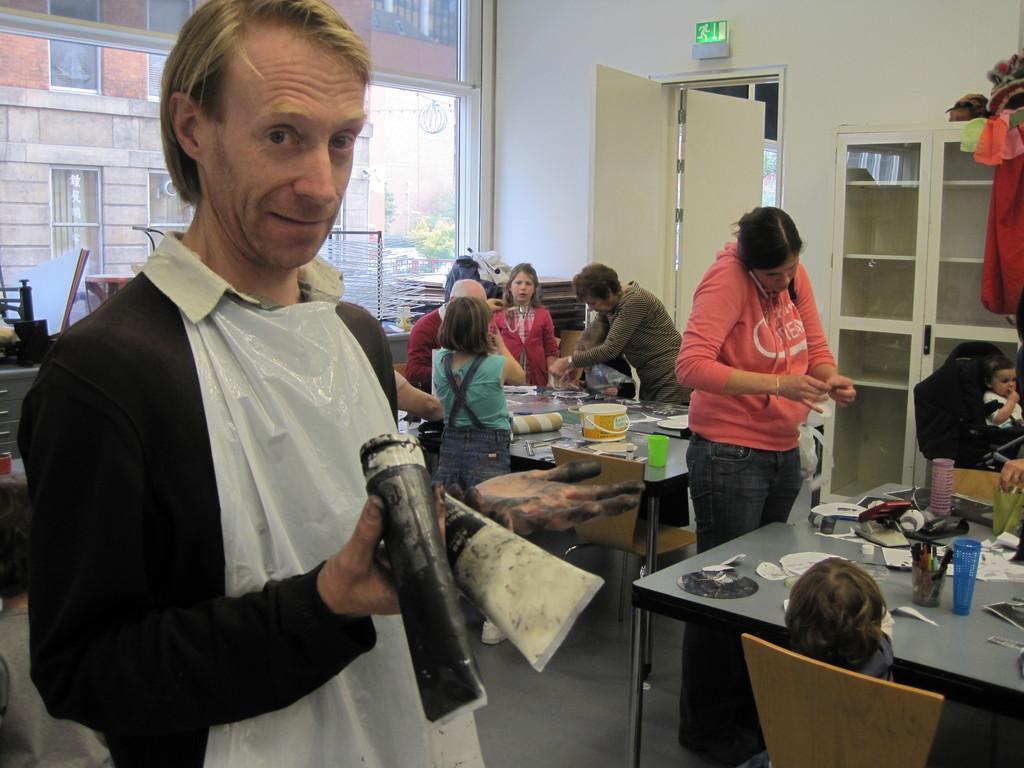Describe this image in one or two sentences. In this image, we can see few peoples are standing. And the left side of the image, man is holding a tube. And he wear a white cloth on his. Here we can see few chairs. Here kid is sat on the chair. There are 2 tables in the room. On top of it, we can see pens stand,paper, photo, holder, here bucket, cloth. Another baby is sat on the stroller. Here we can see glass cupboard and sign here, white door. We can see a white color wall. Behind the people, we can see glass windows. The background we can see a building. Orange color here. Here we can see gray color cupboard. 